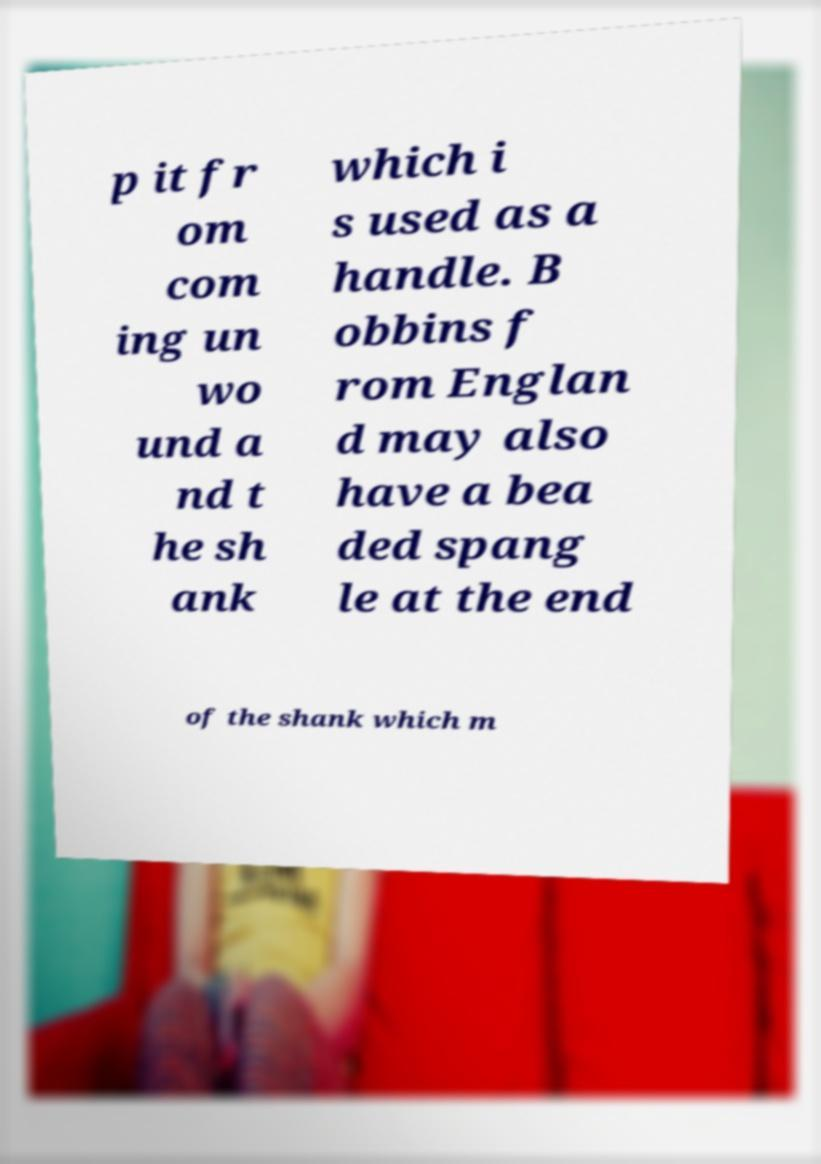There's text embedded in this image that I need extracted. Can you transcribe it verbatim? p it fr om com ing un wo und a nd t he sh ank which i s used as a handle. B obbins f rom Englan d may also have a bea ded spang le at the end of the shank which m 